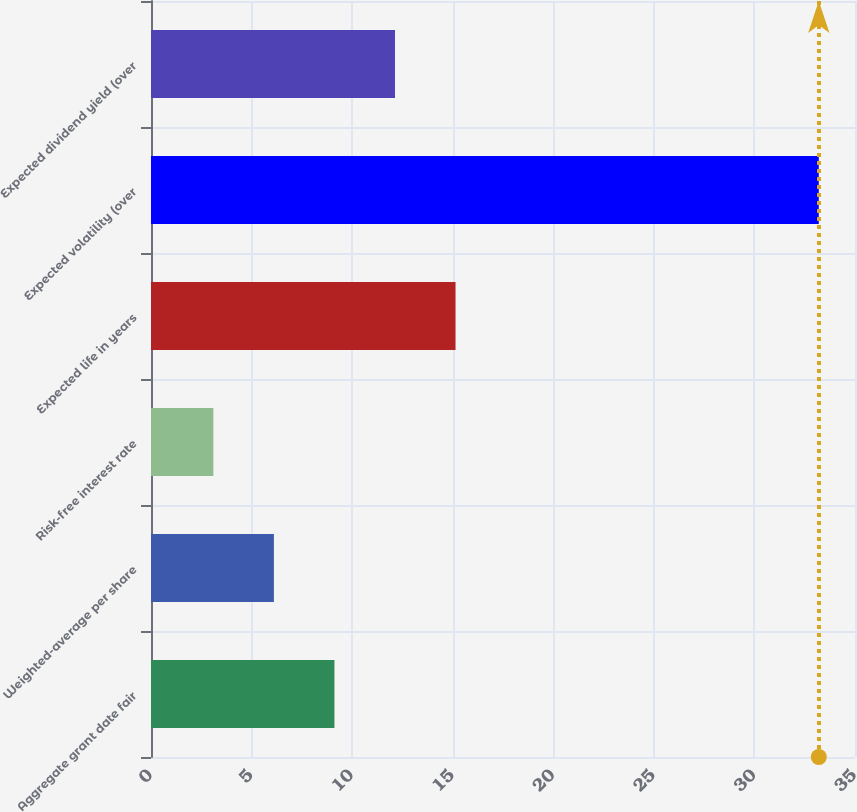Convert chart. <chart><loc_0><loc_0><loc_500><loc_500><bar_chart><fcel>Aggregate grant date fair<fcel>Weighted-average per share<fcel>Risk-free interest rate<fcel>Expected life in years<fcel>Expected volatility (over<fcel>Expected dividend yield (over<nl><fcel>9.12<fcel>6.11<fcel>3.1<fcel>15.14<fcel>33.2<fcel>12.13<nl></chart> 